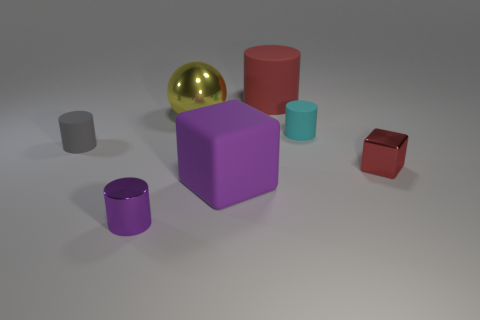What material is the block that is the same size as the red cylinder? Based on the image, the block that appears to be the same size as the red cylinder has a matte finish similar to soft materials like rubber. Therefore, it is plausible that the block is made of rubber. 